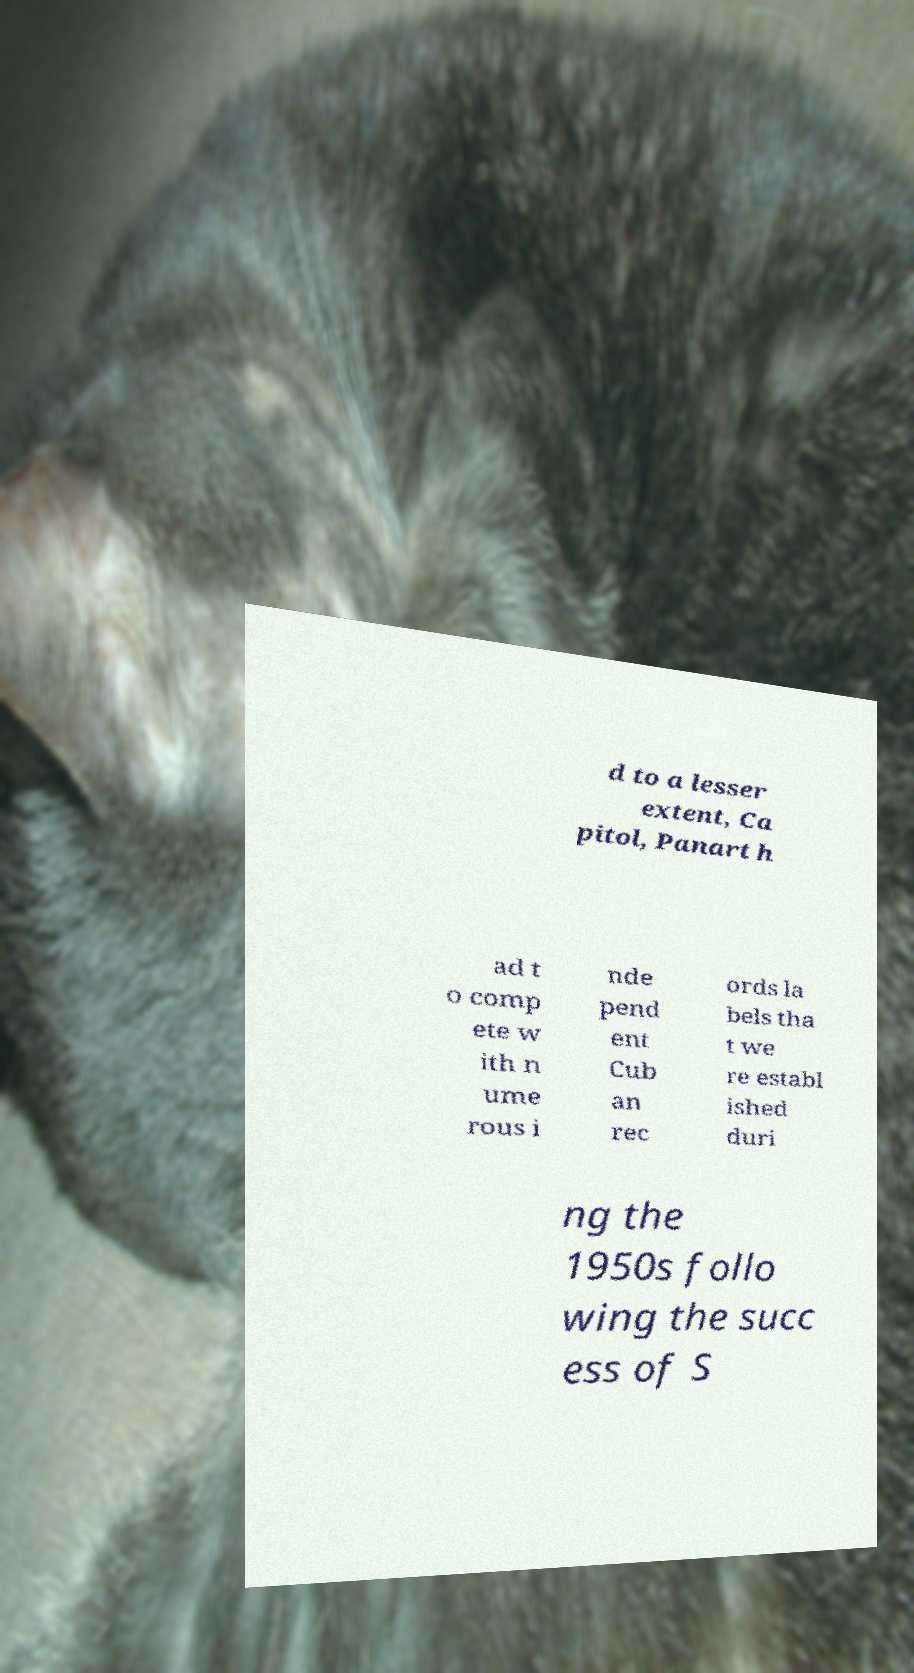For documentation purposes, I need the text within this image transcribed. Could you provide that? d to a lesser extent, Ca pitol, Panart h ad t o comp ete w ith n ume rous i nde pend ent Cub an rec ords la bels tha t we re establ ished duri ng the 1950s follo wing the succ ess of S 